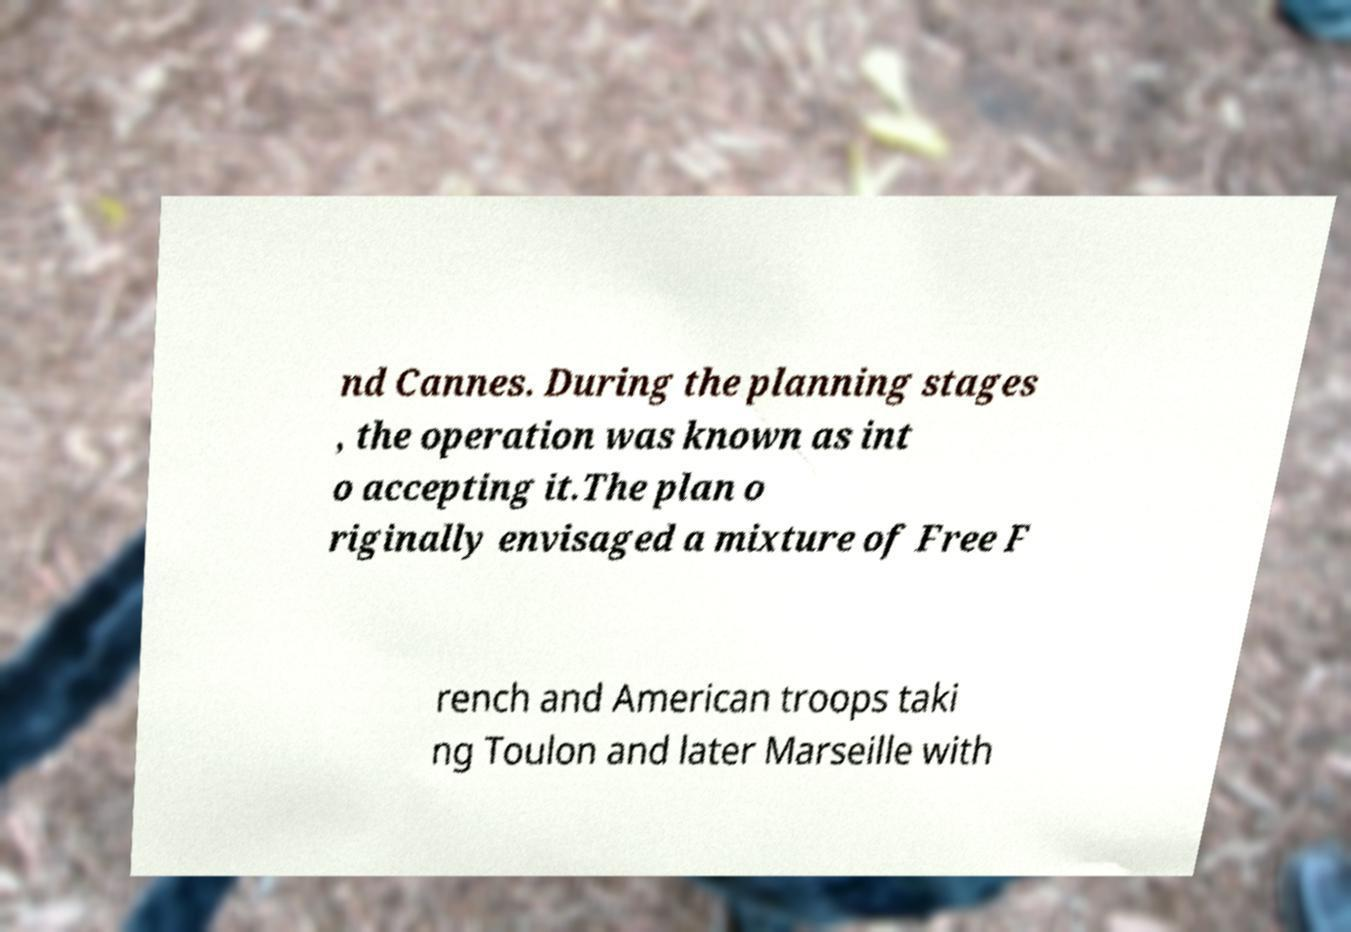Could you extract and type out the text from this image? nd Cannes. During the planning stages , the operation was known as int o accepting it.The plan o riginally envisaged a mixture of Free F rench and American troops taki ng Toulon and later Marseille with 